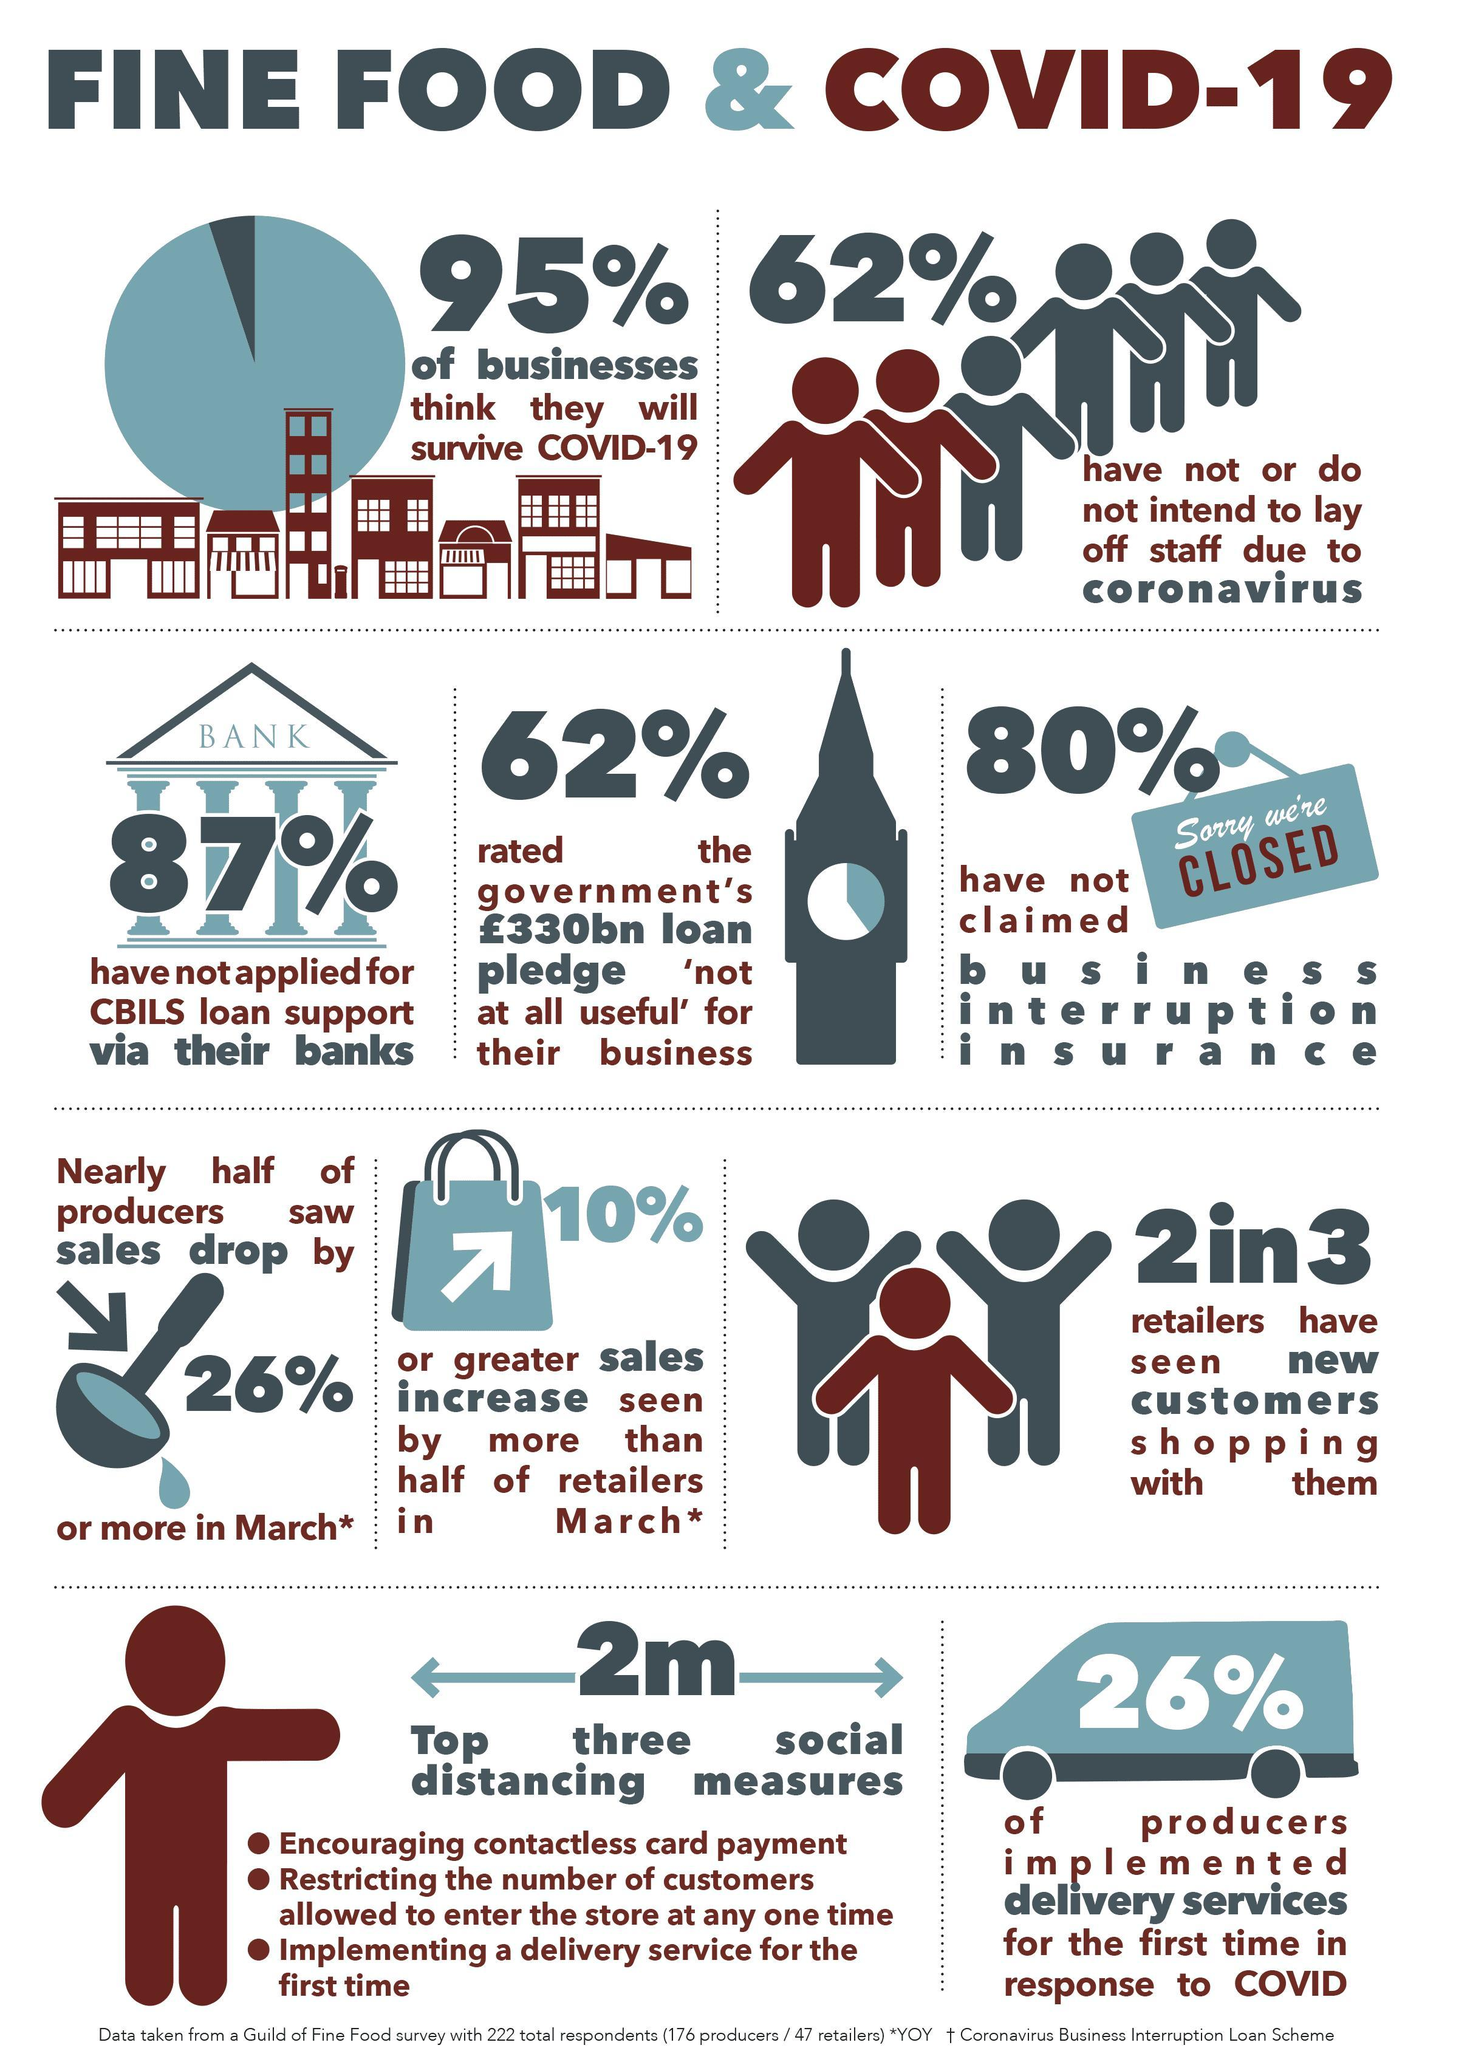What percentage of businesses do not intend to lay of staff due to coronavirus?
Answer the question with a short phrase. 62% What percentage of producers implemented delivery services for the first time in response to COVID? 26% What percentage of businesses think that they will not survive COVID-19? 5% What percentage of businesses have not applied for CBILS loan support  via their banks? 87% What percentage of businesses have claimed business interruption insurance? 20% 